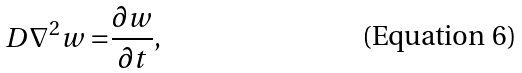<formula> <loc_0><loc_0><loc_500><loc_500>D \nabla ^ { 2 } w = & \frac { \partial w } { \partial t } ,</formula> 